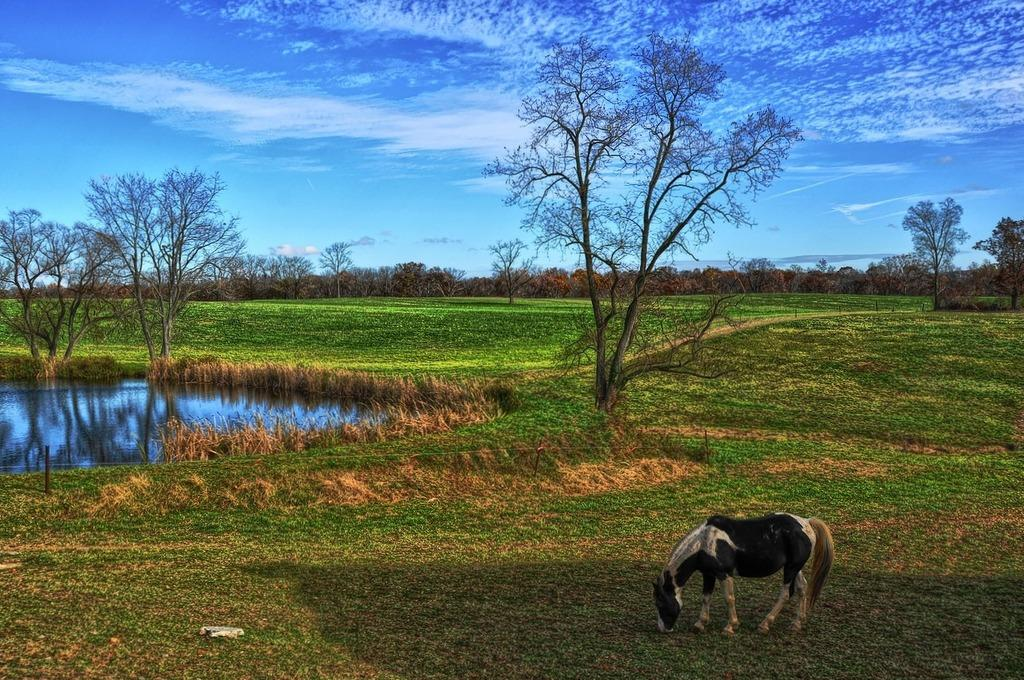What animal is present in the image? There is a horse in the image. What is the horse doing in the image? The horse is standing and eating grass. What can be seen in the background of the image? There is a pond with water, trees, and grass in the image. What is visible in the sky in the image? The sky is visible in the image, and there are clouds present. Where is the pail located in the image? There is no pail present in the image. What type of range is visible in the image? There is no range present in the image. 